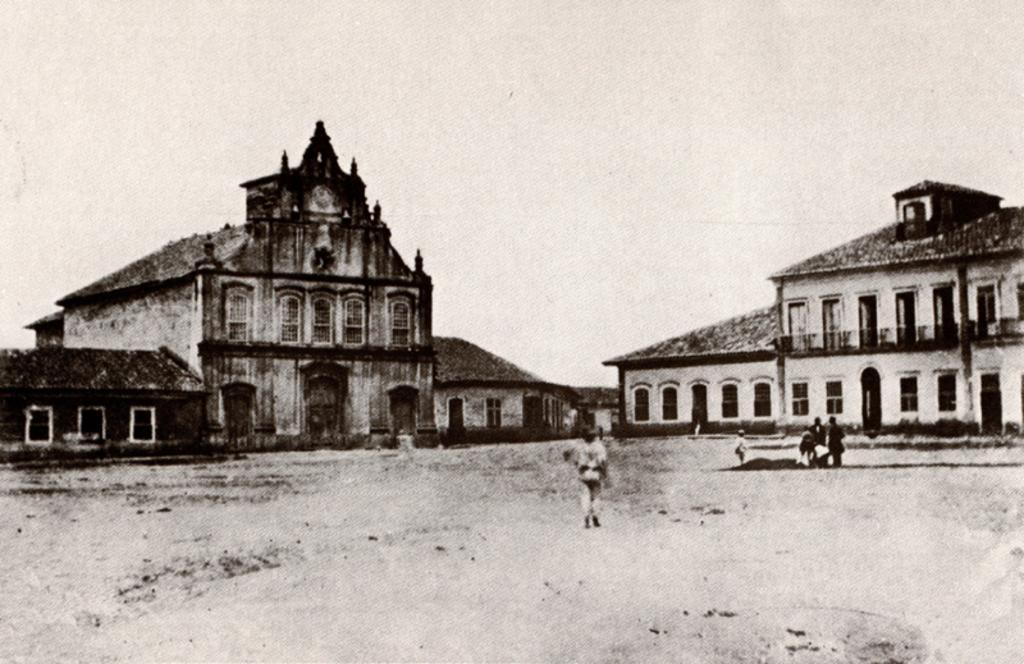Could you give a brief overview of what you see in this image? It is a black and white image, in the middle a person is walking, these are the buildings. At the top it's a cloudy sky. 